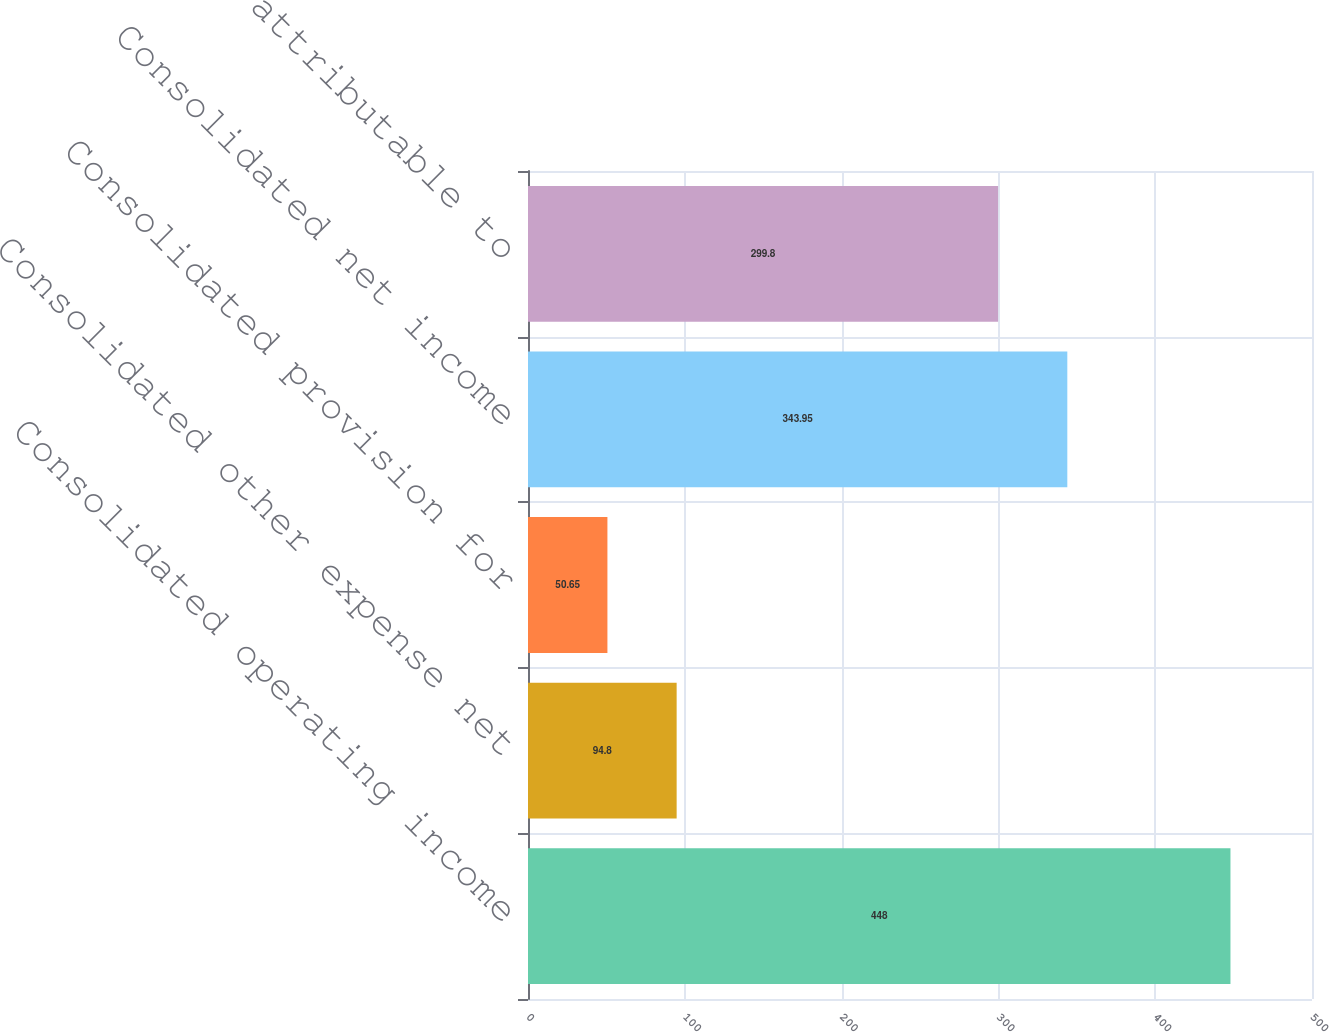Convert chart. <chart><loc_0><loc_0><loc_500><loc_500><bar_chart><fcel>Consolidated operating income<fcel>Consolidated other expense net<fcel>Consolidated provision for<fcel>Consolidated net income<fcel>Net income attributable to<nl><fcel>448<fcel>94.8<fcel>50.65<fcel>343.95<fcel>299.8<nl></chart> 